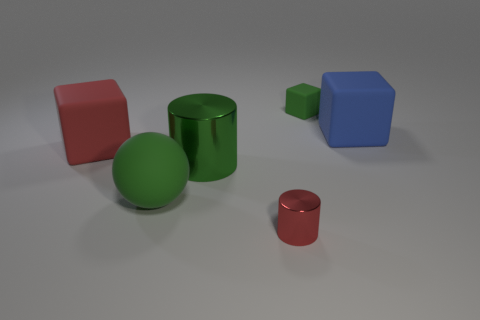Are the objects in the image made of different materials? Yes, the objects in the image seem to be made of different materials. The green sphere and the two cylinders have surfaces that suggest they are metal due to their reflective properties, while the cubes appear to have a matte finish, potentially indicating a plastic or a non-metallic material. 